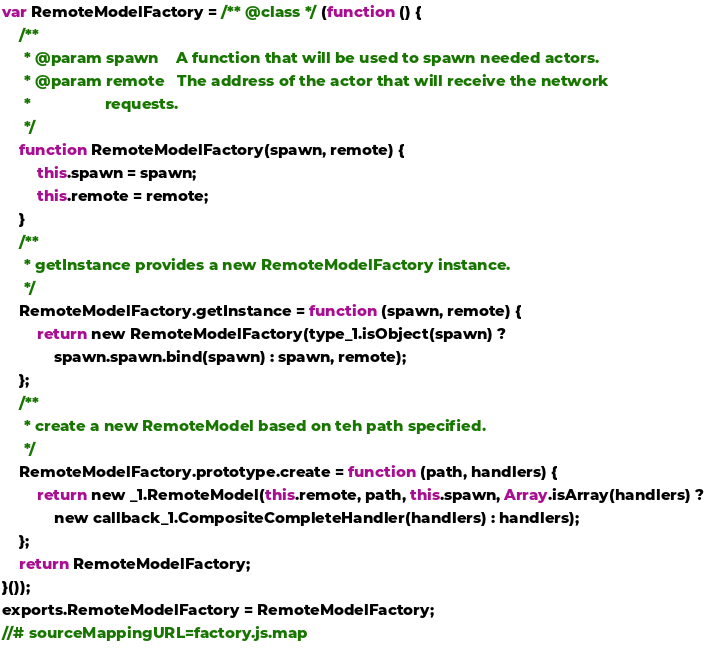Convert code to text. <code><loc_0><loc_0><loc_500><loc_500><_JavaScript_>var RemoteModelFactory = /** @class */ (function () {
    /**
     * @param spawn    A function that will be used to spawn needed actors.
     * @param remote   The address of the actor that will receive the network
     *                 requests.
     */
    function RemoteModelFactory(spawn, remote) {
        this.spawn = spawn;
        this.remote = remote;
    }
    /**
     * getInstance provides a new RemoteModelFactory instance.
     */
    RemoteModelFactory.getInstance = function (spawn, remote) {
        return new RemoteModelFactory(type_1.isObject(spawn) ?
            spawn.spawn.bind(spawn) : spawn, remote);
    };
    /**
     * create a new RemoteModel based on teh path specified.
     */
    RemoteModelFactory.prototype.create = function (path, handlers) {
        return new _1.RemoteModel(this.remote, path, this.spawn, Array.isArray(handlers) ?
            new callback_1.CompositeCompleteHandler(handlers) : handlers);
    };
    return RemoteModelFactory;
}());
exports.RemoteModelFactory = RemoteModelFactory;
//# sourceMappingURL=factory.js.map</code> 